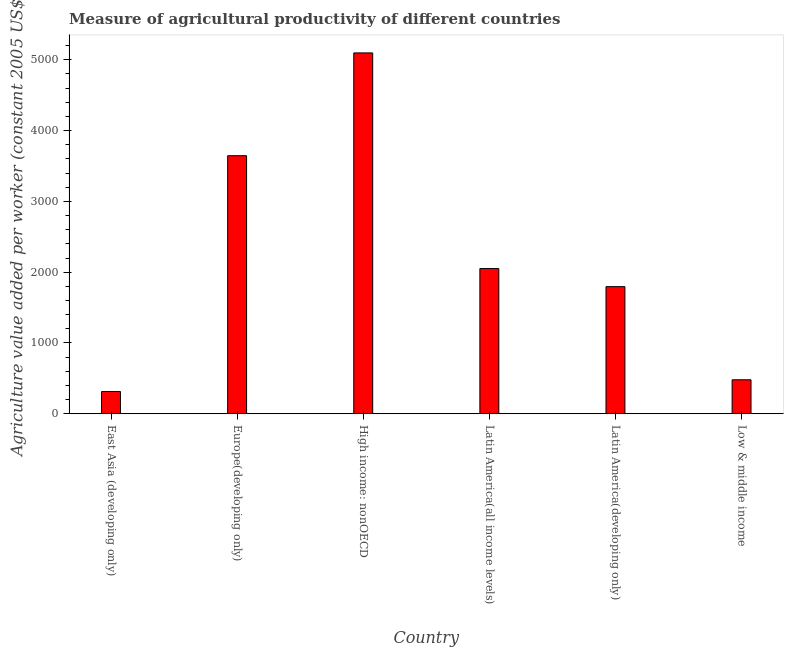Does the graph contain any zero values?
Your answer should be very brief. No. What is the title of the graph?
Your answer should be compact. Measure of agricultural productivity of different countries. What is the label or title of the Y-axis?
Your response must be concise. Agriculture value added per worker (constant 2005 US$). What is the agriculture value added per worker in Europe(developing only)?
Offer a very short reply. 3645.29. Across all countries, what is the maximum agriculture value added per worker?
Ensure brevity in your answer.  5097.39. Across all countries, what is the minimum agriculture value added per worker?
Provide a succinct answer. 314.18. In which country was the agriculture value added per worker maximum?
Offer a terse response. High income: nonOECD. In which country was the agriculture value added per worker minimum?
Provide a short and direct response. East Asia (developing only). What is the sum of the agriculture value added per worker?
Ensure brevity in your answer.  1.34e+04. What is the difference between the agriculture value added per worker in High income: nonOECD and Low & middle income?
Your answer should be very brief. 4617.69. What is the average agriculture value added per worker per country?
Provide a succinct answer. 2230.49. What is the median agriculture value added per worker?
Give a very brief answer. 1923.2. In how many countries, is the agriculture value added per worker greater than 2400 US$?
Your response must be concise. 2. What is the ratio of the agriculture value added per worker in High income: nonOECD to that in Latin America(all income levels)?
Make the answer very short. 2.48. Is the agriculture value added per worker in High income: nonOECD less than that in Low & middle income?
Your response must be concise. No. Is the difference between the agriculture value added per worker in High income: nonOECD and Low & middle income greater than the difference between any two countries?
Make the answer very short. No. What is the difference between the highest and the second highest agriculture value added per worker?
Offer a terse response. 1452.09. Is the sum of the agriculture value added per worker in East Asia (developing only) and Latin America(developing only) greater than the maximum agriculture value added per worker across all countries?
Give a very brief answer. No. What is the difference between the highest and the lowest agriculture value added per worker?
Give a very brief answer. 4783.2. Are all the bars in the graph horizontal?
Your answer should be very brief. No. How many countries are there in the graph?
Your answer should be compact. 6. What is the difference between two consecutive major ticks on the Y-axis?
Make the answer very short. 1000. What is the Agriculture value added per worker (constant 2005 US$) in East Asia (developing only)?
Your answer should be compact. 314.18. What is the Agriculture value added per worker (constant 2005 US$) of Europe(developing only)?
Give a very brief answer. 3645.29. What is the Agriculture value added per worker (constant 2005 US$) of High income: nonOECD?
Your answer should be compact. 5097.39. What is the Agriculture value added per worker (constant 2005 US$) of Latin America(all income levels)?
Offer a terse response. 2051.01. What is the Agriculture value added per worker (constant 2005 US$) in Latin America(developing only)?
Provide a succinct answer. 1795.38. What is the Agriculture value added per worker (constant 2005 US$) in Low & middle income?
Your response must be concise. 479.69. What is the difference between the Agriculture value added per worker (constant 2005 US$) in East Asia (developing only) and Europe(developing only)?
Provide a short and direct response. -3331.11. What is the difference between the Agriculture value added per worker (constant 2005 US$) in East Asia (developing only) and High income: nonOECD?
Your answer should be very brief. -4783.2. What is the difference between the Agriculture value added per worker (constant 2005 US$) in East Asia (developing only) and Latin America(all income levels)?
Offer a terse response. -1736.82. What is the difference between the Agriculture value added per worker (constant 2005 US$) in East Asia (developing only) and Latin America(developing only)?
Offer a terse response. -1481.2. What is the difference between the Agriculture value added per worker (constant 2005 US$) in East Asia (developing only) and Low & middle income?
Your answer should be compact. -165.51. What is the difference between the Agriculture value added per worker (constant 2005 US$) in Europe(developing only) and High income: nonOECD?
Make the answer very short. -1452.09. What is the difference between the Agriculture value added per worker (constant 2005 US$) in Europe(developing only) and Latin America(all income levels)?
Offer a terse response. 1594.29. What is the difference between the Agriculture value added per worker (constant 2005 US$) in Europe(developing only) and Latin America(developing only)?
Your answer should be compact. 1849.91. What is the difference between the Agriculture value added per worker (constant 2005 US$) in Europe(developing only) and Low & middle income?
Your answer should be very brief. 3165.6. What is the difference between the Agriculture value added per worker (constant 2005 US$) in High income: nonOECD and Latin America(all income levels)?
Your answer should be very brief. 3046.38. What is the difference between the Agriculture value added per worker (constant 2005 US$) in High income: nonOECD and Latin America(developing only)?
Give a very brief answer. 3302. What is the difference between the Agriculture value added per worker (constant 2005 US$) in High income: nonOECD and Low & middle income?
Make the answer very short. 4617.69. What is the difference between the Agriculture value added per worker (constant 2005 US$) in Latin America(all income levels) and Latin America(developing only)?
Offer a very short reply. 255.62. What is the difference between the Agriculture value added per worker (constant 2005 US$) in Latin America(all income levels) and Low & middle income?
Offer a terse response. 1571.31. What is the difference between the Agriculture value added per worker (constant 2005 US$) in Latin America(developing only) and Low & middle income?
Your answer should be compact. 1315.69. What is the ratio of the Agriculture value added per worker (constant 2005 US$) in East Asia (developing only) to that in Europe(developing only)?
Make the answer very short. 0.09. What is the ratio of the Agriculture value added per worker (constant 2005 US$) in East Asia (developing only) to that in High income: nonOECD?
Keep it short and to the point. 0.06. What is the ratio of the Agriculture value added per worker (constant 2005 US$) in East Asia (developing only) to that in Latin America(all income levels)?
Provide a short and direct response. 0.15. What is the ratio of the Agriculture value added per worker (constant 2005 US$) in East Asia (developing only) to that in Latin America(developing only)?
Make the answer very short. 0.17. What is the ratio of the Agriculture value added per worker (constant 2005 US$) in East Asia (developing only) to that in Low & middle income?
Give a very brief answer. 0.66. What is the ratio of the Agriculture value added per worker (constant 2005 US$) in Europe(developing only) to that in High income: nonOECD?
Your response must be concise. 0.71. What is the ratio of the Agriculture value added per worker (constant 2005 US$) in Europe(developing only) to that in Latin America(all income levels)?
Your response must be concise. 1.78. What is the ratio of the Agriculture value added per worker (constant 2005 US$) in Europe(developing only) to that in Latin America(developing only)?
Make the answer very short. 2.03. What is the ratio of the Agriculture value added per worker (constant 2005 US$) in Europe(developing only) to that in Low & middle income?
Make the answer very short. 7.6. What is the ratio of the Agriculture value added per worker (constant 2005 US$) in High income: nonOECD to that in Latin America(all income levels)?
Your response must be concise. 2.48. What is the ratio of the Agriculture value added per worker (constant 2005 US$) in High income: nonOECD to that in Latin America(developing only)?
Provide a succinct answer. 2.84. What is the ratio of the Agriculture value added per worker (constant 2005 US$) in High income: nonOECD to that in Low & middle income?
Your answer should be compact. 10.63. What is the ratio of the Agriculture value added per worker (constant 2005 US$) in Latin America(all income levels) to that in Latin America(developing only)?
Provide a succinct answer. 1.14. What is the ratio of the Agriculture value added per worker (constant 2005 US$) in Latin America(all income levels) to that in Low & middle income?
Offer a very short reply. 4.28. What is the ratio of the Agriculture value added per worker (constant 2005 US$) in Latin America(developing only) to that in Low & middle income?
Offer a very short reply. 3.74. 